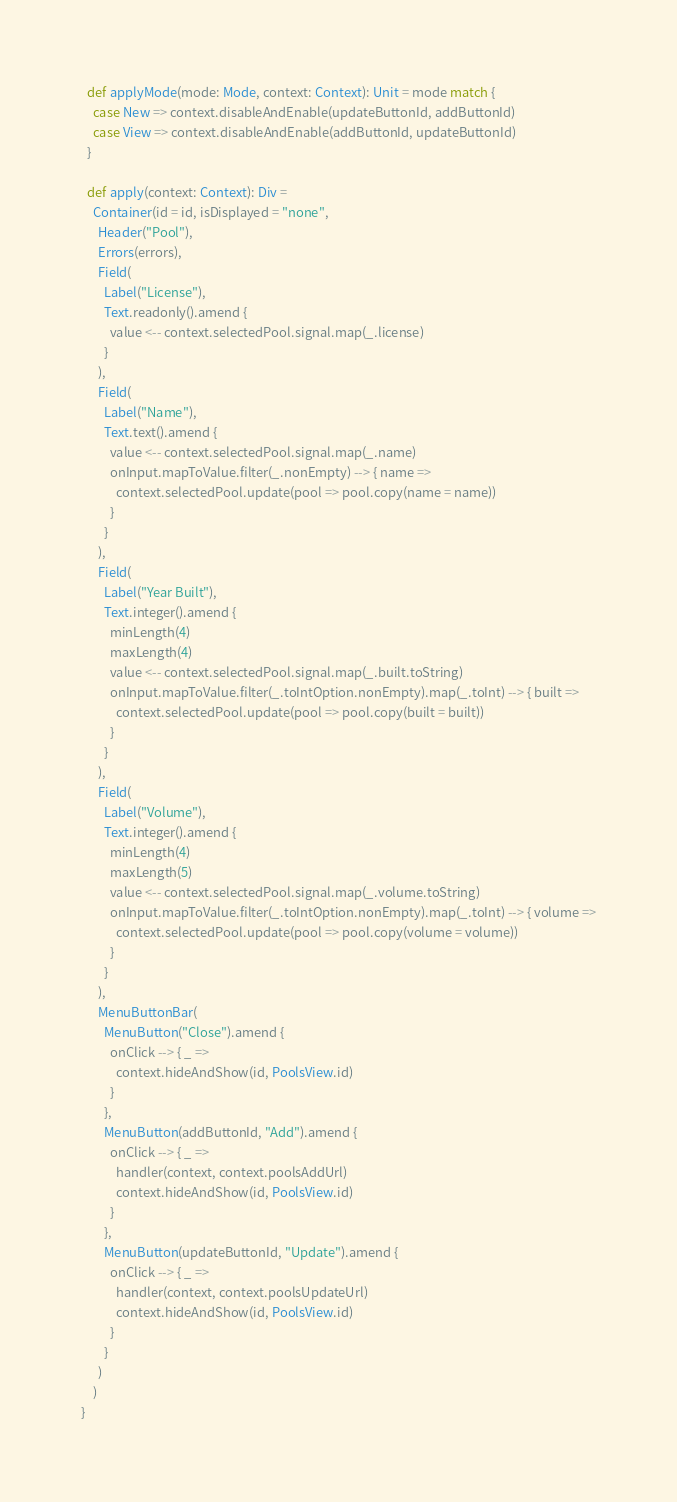<code> <loc_0><loc_0><loc_500><loc_500><_Scala_>  def applyMode(mode: Mode, context: Context): Unit = mode match {
    case New => context.disableAndEnable(updateButtonId, addButtonId)
    case View => context.disableAndEnable(addButtonId, updateButtonId)
  }

  def apply(context: Context): Div =
    Container(id = id, isDisplayed = "none",
      Header("Pool"),
      Errors(errors),
      Field(
        Label("License"),
        Text.readonly().amend {
          value <-- context.selectedPool.signal.map(_.license)
        }
      ),
      Field(
        Label("Name"),
        Text.text().amend {
          value <-- context.selectedPool.signal.map(_.name)
          onInput.mapToValue.filter(_.nonEmpty) --> { name =>
            context.selectedPool.update(pool => pool.copy(name = name))
          }
        }
      ),
      Field(
        Label("Year Built"),
        Text.integer().amend {
          minLength(4)
          maxLength(4)
          value <-- context.selectedPool.signal.map(_.built.toString)
          onInput.mapToValue.filter(_.toIntOption.nonEmpty).map(_.toInt) --> { built =>
            context.selectedPool.update(pool => pool.copy(built = built))
          }
        }
      ),
      Field(
        Label("Volume"),
        Text.integer().amend {
          minLength(4)
          maxLength(5)
          value <-- context.selectedPool.signal.map(_.volume.toString)
          onInput.mapToValue.filter(_.toIntOption.nonEmpty).map(_.toInt) --> { volume =>
            context.selectedPool.update(pool => pool.copy(volume = volume))
          }
        }
      ),
      MenuButtonBar(
        MenuButton("Close").amend {
          onClick --> { _ =>
            context.hideAndShow(id, PoolsView.id)
          }
        },
        MenuButton(addButtonId, "Add").amend {
          onClick --> { _ =>
            handler(context, context.poolsAddUrl)
            context.hideAndShow(id, PoolsView.id)
          }
        },
        MenuButton(updateButtonId, "Update").amend {
          onClick --> { _ =>
            handler(context, context.poolsUpdateUrl)
            context.hideAndShow(id, PoolsView.id)
          }
        }
      )
    )
}</code> 